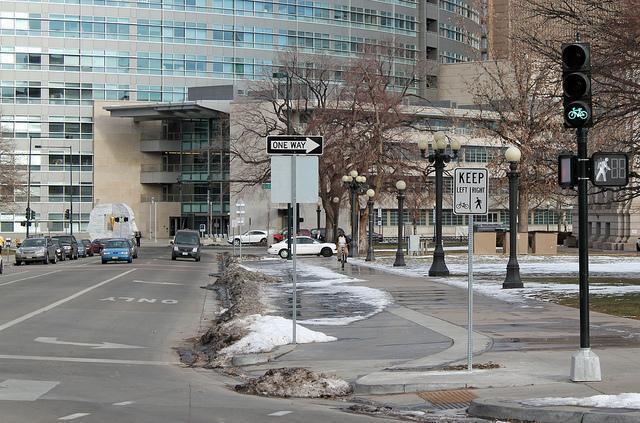How many traffic lights can you see?
Give a very brief answer. 1. 